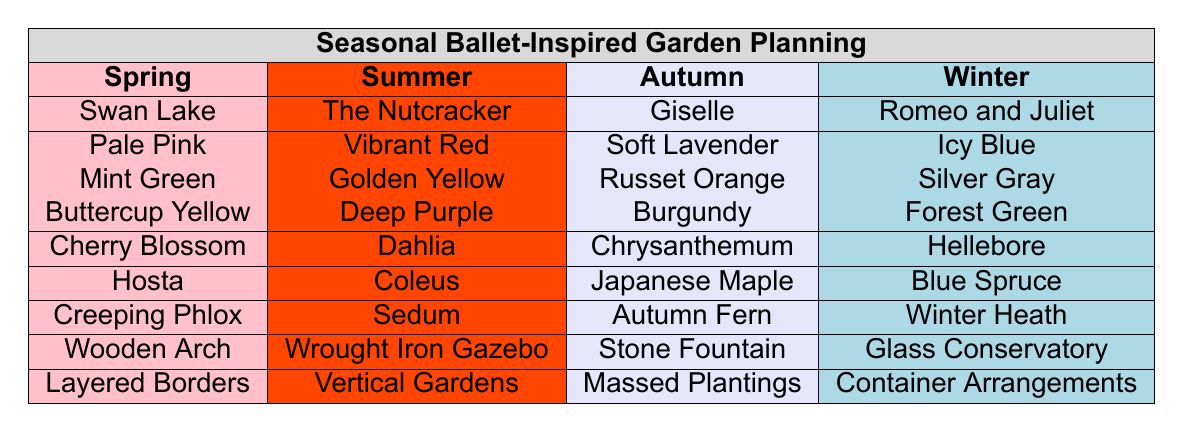What is the primary color associated with Summer? The table indicates that the primary color for Summer is Vibrant Red.
Answer: Vibrant Red Which flowering plant is recommended for Autumn? According to the table, the flowering plant suggested for Autumn is Chrysanthemum.
Answer: Chrysanthemum Is Mint Green an accent color for Spring? The table lists Mint Green as a secondary color for Spring, not an accent color. Therefore, the statement is false.
Answer: No Which season features the ballet inspiration "Swan Lake"? The table shows that "Swan Lake" is associated with the Spring season.
Answer: Spring What are the two foliage plants listed for Winter? From the table, the two foliage plants for Winter are Blue Spruce and Silver Gray (as a secondary color). Therefore, only one foliage plant is noted.
Answer: Blue Spruce Which garden structure is associated with Autumn? The table indicates that the garden structure suggested for Autumn is the Stone Fountain.
Answer: Stone Fountain How many accent colors are listed for Summer? The table shows three accent colors for Summer: Buttercup Yellow, Deep Purple, and Burgundy. Thus the count is three.
Answer: Three Identify the season that inspires "Romeo and Juliet." "Romeo and Juliet" is noted in the table as the ballet inspiration for Winter.
Answer: Winter Which planting technique appears in Spring? Layered Borders is the planting technique listed under the Spring season in the table.
Answer: Layered Borders If a gardener wants a color palette that combines the primary and secondary colors of Autumn, what colors would they use? The primary color for Autumn is Soft Lavender, and the secondary color is Russet Orange. Therefore, the combined palette would include Soft Lavender and Russet Orange.
Answer: Soft Lavender and Russet Orange 